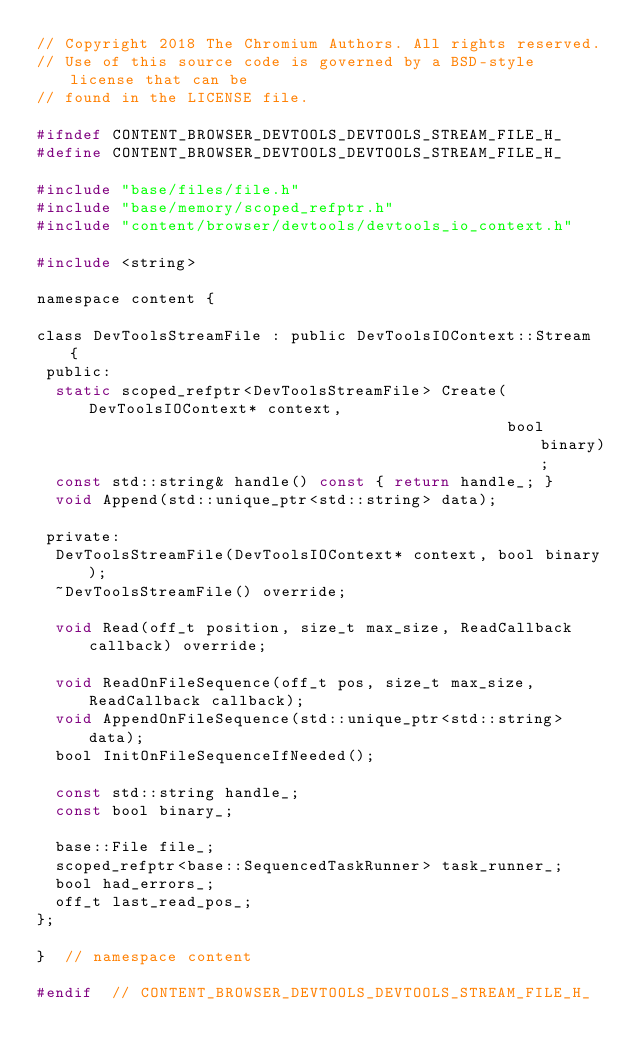<code> <loc_0><loc_0><loc_500><loc_500><_C_>// Copyright 2018 The Chromium Authors. All rights reserved.
// Use of this source code is governed by a BSD-style license that can be
// found in the LICENSE file.

#ifndef CONTENT_BROWSER_DEVTOOLS_DEVTOOLS_STREAM_FILE_H_
#define CONTENT_BROWSER_DEVTOOLS_DEVTOOLS_STREAM_FILE_H_

#include "base/files/file.h"
#include "base/memory/scoped_refptr.h"
#include "content/browser/devtools/devtools_io_context.h"

#include <string>

namespace content {

class DevToolsStreamFile : public DevToolsIOContext::Stream {
 public:
  static scoped_refptr<DevToolsStreamFile> Create(DevToolsIOContext* context,
                                                  bool binary);
  const std::string& handle() const { return handle_; }
  void Append(std::unique_ptr<std::string> data);

 private:
  DevToolsStreamFile(DevToolsIOContext* context, bool binary);
  ~DevToolsStreamFile() override;

  void Read(off_t position, size_t max_size, ReadCallback callback) override;

  void ReadOnFileSequence(off_t pos, size_t max_size, ReadCallback callback);
  void AppendOnFileSequence(std::unique_ptr<std::string> data);
  bool InitOnFileSequenceIfNeeded();

  const std::string handle_;
  const bool binary_;

  base::File file_;
  scoped_refptr<base::SequencedTaskRunner> task_runner_;
  bool had_errors_;
  off_t last_read_pos_;
};

}  // namespace content

#endif  // CONTENT_BROWSER_DEVTOOLS_DEVTOOLS_STREAM_FILE_H_
</code> 